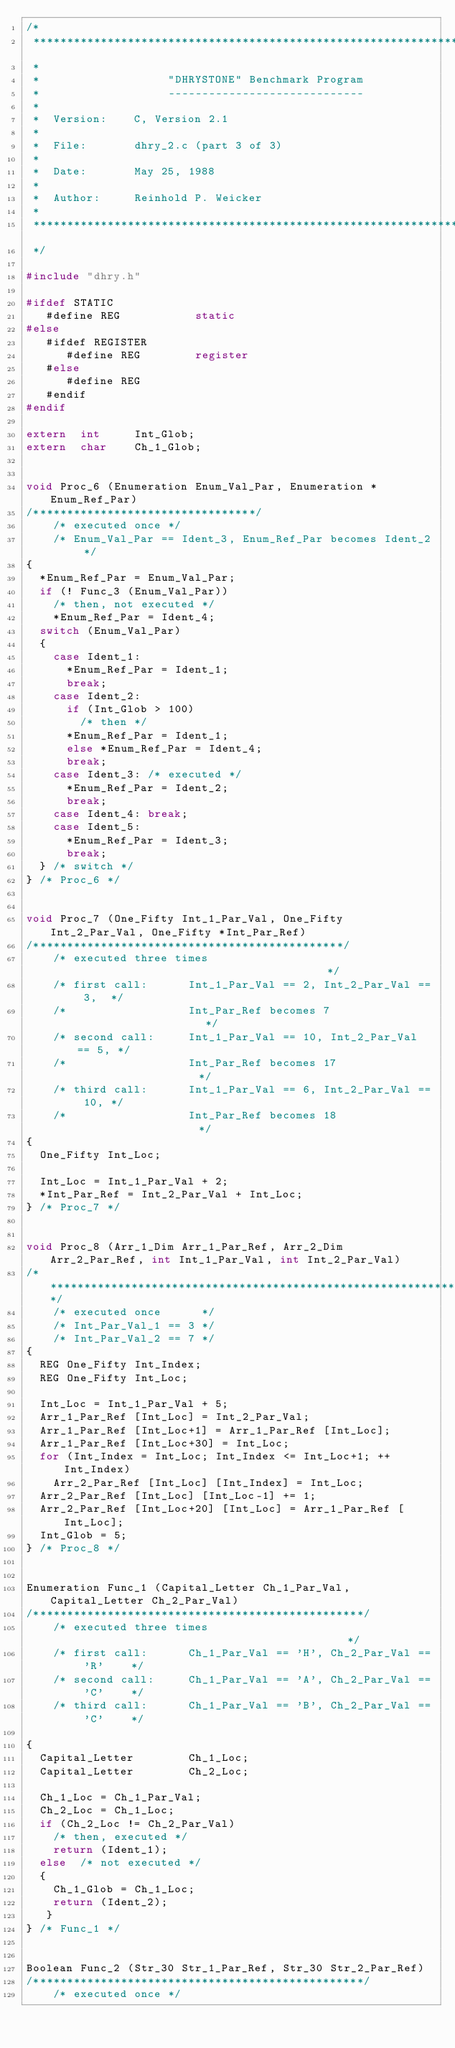<code> <loc_0><loc_0><loc_500><loc_500><_C_>/*
 ****************************************************************************
 *
 *                   "DHRYSTONE" Benchmark Program
 *                   -----------------------------
 *                                                                            
 *  Version:    C, Version 2.1
 *                                                                            
 *  File:       dhry_2.c (part 3 of 3)
 *
 *  Date:       May 25, 1988
 *
 *  Author:     Reinhold P. Weicker
 *
 ****************************************************************************
 */

#include "dhry.h"

#ifdef STATIC
   #define REG           static
#else
   #ifdef REGISTER
      #define REG        register
   #else
      #define REG
   #endif
#endif

extern  int     Int_Glob;
extern  char    Ch_1_Glob;


void Proc_6 (Enumeration Enum_Val_Par, Enumeration *Enum_Ref_Par)
/*********************************/
    /* executed once */
    /* Enum_Val_Par == Ident_3, Enum_Ref_Par becomes Ident_2 */
{
  *Enum_Ref_Par = Enum_Val_Par;
  if (! Func_3 (Enum_Val_Par))
    /* then, not executed */
    *Enum_Ref_Par = Ident_4;
  switch (Enum_Val_Par)
  {
    case Ident_1: 
      *Enum_Ref_Par = Ident_1;
      break;
    case Ident_2: 
      if (Int_Glob > 100)
        /* then */
      *Enum_Ref_Par = Ident_1;
      else *Enum_Ref_Par = Ident_4;
      break;
    case Ident_3: /* executed */
      *Enum_Ref_Par = Ident_2;
      break;
    case Ident_4: break;
    case Ident_5: 
      *Enum_Ref_Par = Ident_3;
      break;
  } /* switch */
} /* Proc_6 */


void Proc_7 (One_Fifty Int_1_Par_Val, One_Fifty Int_2_Par_Val, One_Fifty *Int_Par_Ref)
/**********************************************/
    /* executed three times                                      */ 
    /* first call:      Int_1_Par_Val == 2, Int_2_Par_Val == 3,  */
    /*                  Int_Par_Ref becomes 7                    */
    /* second call:     Int_1_Par_Val == 10, Int_2_Par_Val == 5, */
    /*                  Int_Par_Ref becomes 17                   */
    /* third call:      Int_1_Par_Val == 6, Int_2_Par_Val == 10, */
    /*                  Int_Par_Ref becomes 18                   */
{
  One_Fifty Int_Loc;

  Int_Loc = Int_1_Par_Val + 2;
  *Int_Par_Ref = Int_2_Par_Val + Int_Loc;
} /* Proc_7 */


void Proc_8 (Arr_1_Dim Arr_1_Par_Ref, Arr_2_Dim Arr_2_Par_Ref, int Int_1_Par_Val, int Int_2_Par_Val)
/*********************************************************************/
    /* executed once      */
    /* Int_Par_Val_1 == 3 */
    /* Int_Par_Val_2 == 7 */
{
  REG One_Fifty Int_Index;
  REG One_Fifty Int_Loc;

  Int_Loc = Int_1_Par_Val + 5;
  Arr_1_Par_Ref [Int_Loc] = Int_2_Par_Val;
  Arr_1_Par_Ref [Int_Loc+1] = Arr_1_Par_Ref [Int_Loc];
  Arr_1_Par_Ref [Int_Loc+30] = Int_Loc;
  for (Int_Index = Int_Loc; Int_Index <= Int_Loc+1; ++Int_Index)
    Arr_2_Par_Ref [Int_Loc] [Int_Index] = Int_Loc;
  Arr_2_Par_Ref [Int_Loc] [Int_Loc-1] += 1;
  Arr_2_Par_Ref [Int_Loc+20] [Int_Loc] = Arr_1_Par_Ref [Int_Loc];
  Int_Glob = 5;
} /* Proc_8 */


Enumeration Func_1 (Capital_Letter Ch_1_Par_Val, Capital_Letter Ch_2_Par_Val)
/*************************************************/
    /* executed three times                                         */
    /* first call:      Ch_1_Par_Val == 'H', Ch_2_Par_Val == 'R'    */
    /* second call:     Ch_1_Par_Val == 'A', Ch_2_Par_Val == 'C'    */
    /* third call:      Ch_1_Par_Val == 'B', Ch_2_Par_Val == 'C'    */

{
  Capital_Letter        Ch_1_Loc;
  Capital_Letter        Ch_2_Loc;

  Ch_1_Loc = Ch_1_Par_Val;
  Ch_2_Loc = Ch_1_Loc;
  if (Ch_2_Loc != Ch_2_Par_Val)
    /* then, executed */
    return (Ident_1);
  else  /* not executed */
  {
    Ch_1_Glob = Ch_1_Loc;
    return (Ident_2);
   }
} /* Func_1 */


Boolean Func_2 (Str_30 Str_1_Par_Ref, Str_30 Str_2_Par_Ref)
/*************************************************/
    /* executed once */</code> 